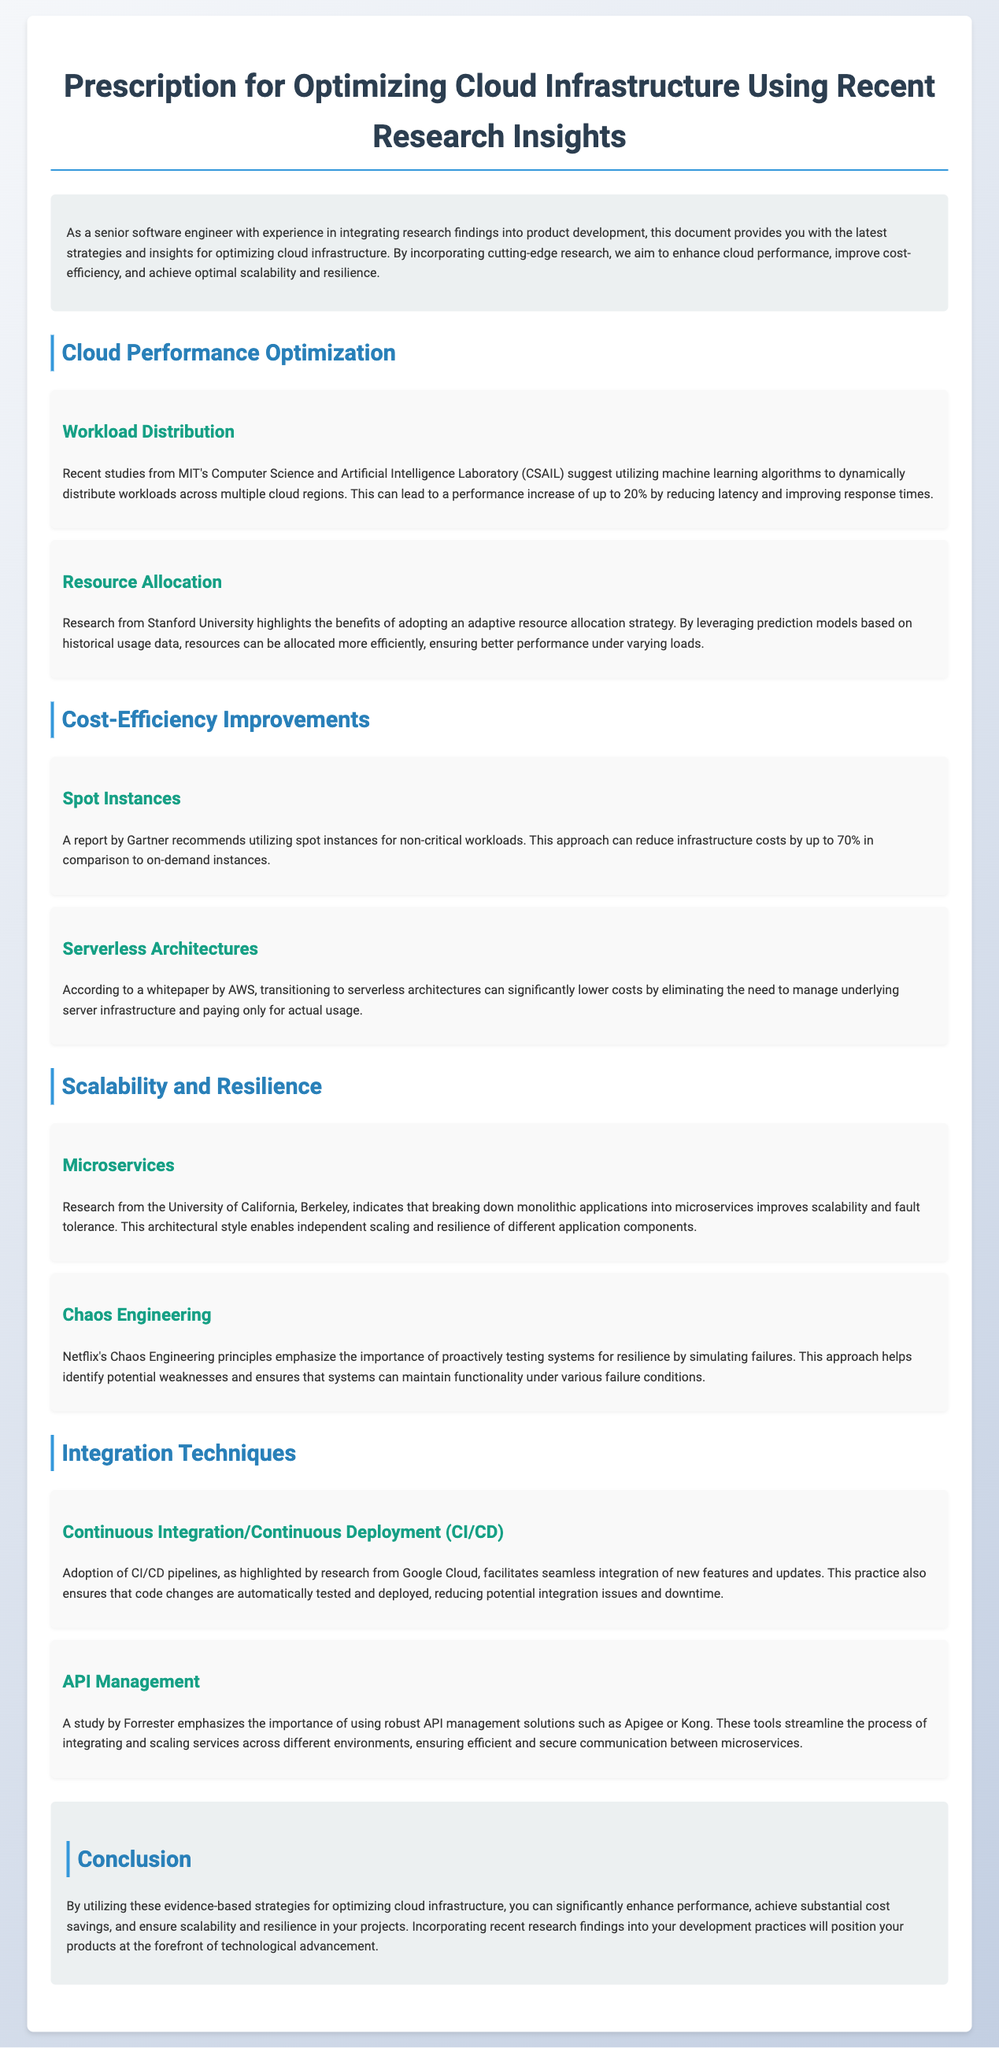What is the main focus of the document? The document is centered on strategies and insights for optimizing cloud infrastructure, which improves performance, cost-efficiency, scalability, and resilience.
Answer: Optimizing cloud infrastructure Which university conducted research on workload distribution? The document mentions a study on workload distribution by MIT's Computer Science and Artificial Intelligence Laboratory.
Answer: MIT What percentage performance increase can be achieved through dynamic workload distribution? The document states that a performance increase of up to 20% can be achieved by dynamic workload distribution.
Answer: 20% How much can infrastructure costs be reduced by using spot instances? According to the report by Gartner, infrastructure costs can be reduced by up to 70% using spot instances.
Answer: 70% What architectural style improves scalability and fault tolerance? The document indicates that breaking down monolithic applications into microservices enhances scalability and fault tolerance.
Answer: Microservices What technique is emphasized by Netflix for testing system resilience? The document reveals that Chaos Engineering principles are used by Netflix for testing system resilience by simulating failures.
Answer: Chaos Engineering What does CI/CD stand for? The document refers to Continuous Integration/Continuous Deployment as CI/CD.
Answer: Continuous Integration/Continuous Deployment Which API management solutions are mentioned in the document? The document highlights the use of tools like Apigee or Kong for robust API management.
Answer: Apigee or Kong What is the conclusion of the document? The conclusion summarizes that utilizing evidence-based strategies for optimizing cloud infrastructure leads to enhanced performance, cost savings, scalability, and resilience.
Answer: Evidence-based strategies for optimizing cloud infrastructure 